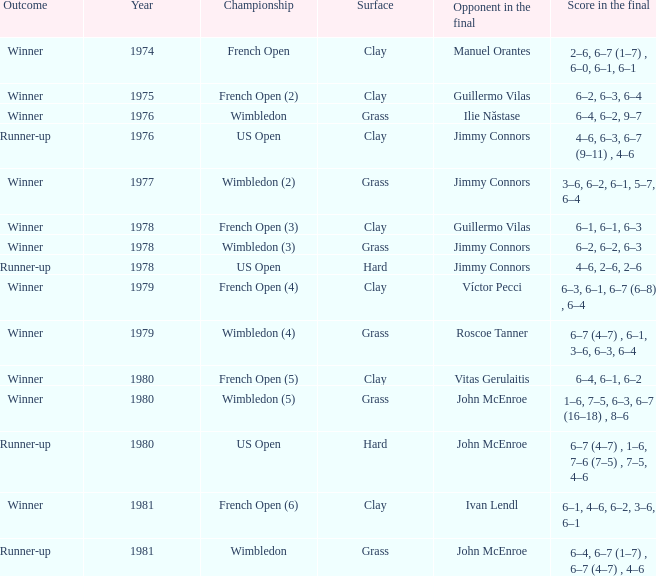What are all the scores in the final for the competitor in the final john mcenroe at the us open? 6–7 (4–7) , 1–6, 7–6 (7–5) , 7–5, 4–6. 